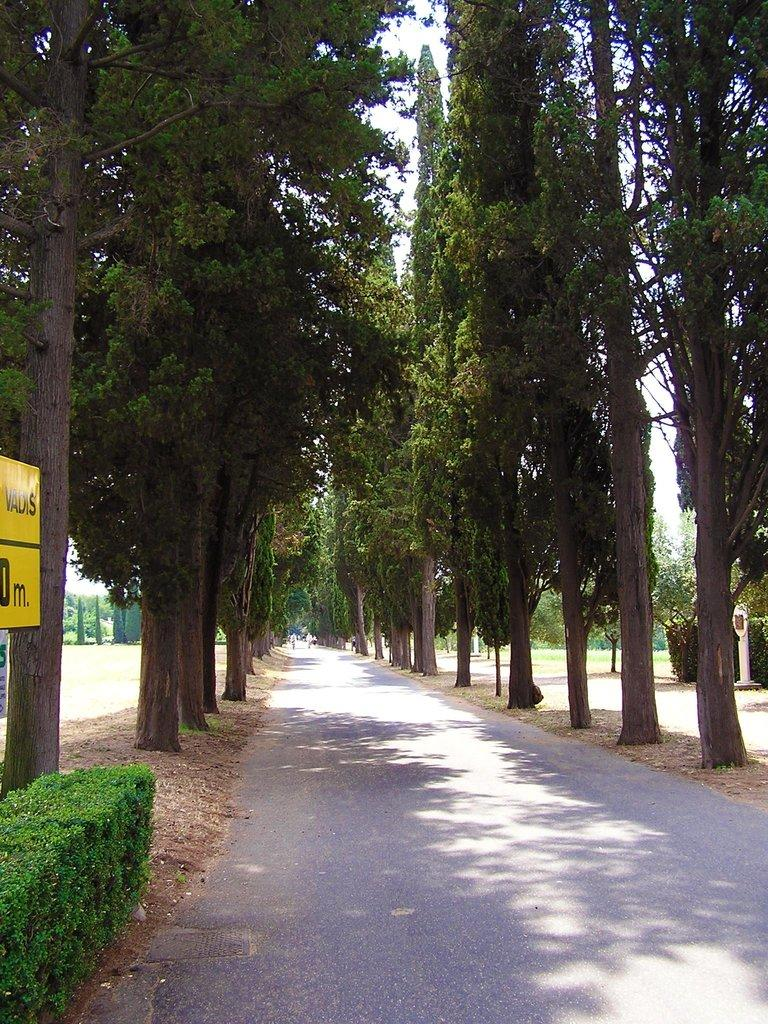What is the main feature of the image? There is a road in the image. What can be seen alongside the road? There are trees and plants in the image. Where is the yellow board with text located? The yellow board with text is on the left side of the image. How much debt is represented by the trees in the image? There is no mention of debt in the image, and the trees do not represent any financial concept. 